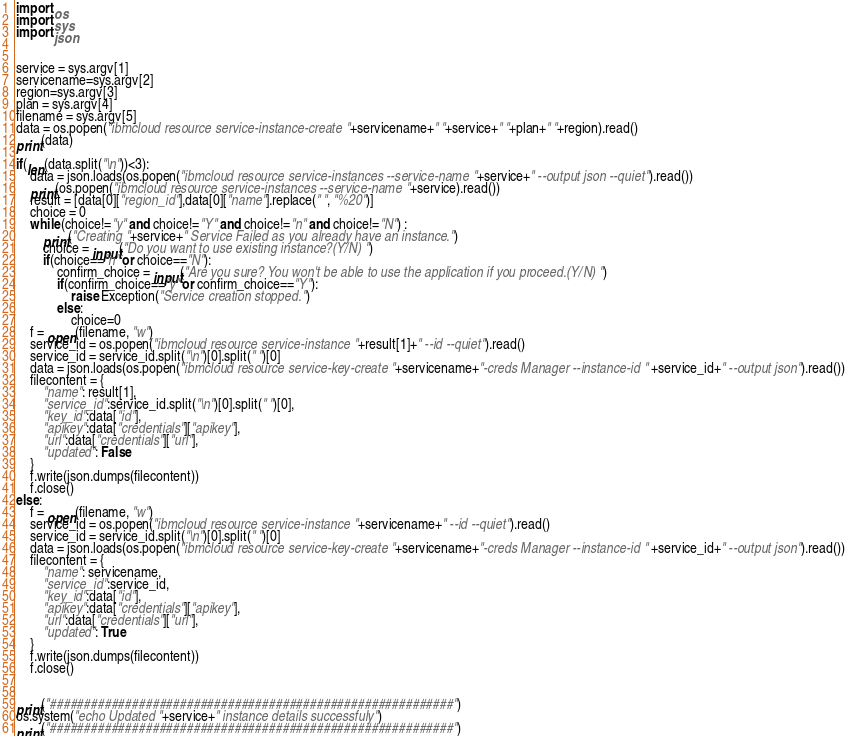Convert code to text. <code><loc_0><loc_0><loc_500><loc_500><_Python_>import os
import sys
import json


service = sys.argv[1]
servicename=sys.argv[2]
region=sys.argv[3]
plan = sys.argv[4]
filename = sys.argv[5]
data = os.popen("ibmcloud resource service-instance-create "+servicename+" "+service+" "+plan+" "+region).read()
print(data)

if(len(data.split("\n"))<3):
    data = json.loads(os.popen("ibmcloud resource service-instances --service-name "+service+" --output json --quiet").read())
    print(os.popen("ibmcloud resource service-instances --service-name "+service).read())
    result = [data[0]["region_id"],data[0]["name"].replace(" ", "%20")]
    choice = 0
    while (choice!="y" and choice!="Y" and choice!="n" and choice!="N") :
        print("Creating "+service+" Service Failed as you already have an instance.")
        choice = input("Do you want to use existing instance?(Y/N) ")
        if(choice=="n" or choice=="N"):
            confirm_choice = input("Are you sure? You won't be able to use the application if you proceed.(Y/N) ")
            if(confirm_choice=="y" or confirm_choice=="Y"):
                raise Exception("Service creation stopped.")
            else:
                choice=0
    f = open(filename, "w")
    service_id = os.popen("ibmcloud resource service-instance "+result[1]+" --id --quiet").read()
    service_id = service_id.split("\n")[0].split(" ")[0]
    data = json.loads(os.popen("ibmcloud resource service-key-create "+servicename+"-creds Manager --instance-id " +service_id+" --output json").read())
    filecontent = {
        "name": result[1],
        "service_id":service_id.split("\n")[0].split(" ")[0],
        "key_id":data["id"],
        "apikey":data["credentials"]["apikey"],
        "url":data["credentials"]["url"],
        "updated": False
    }
    f.write(json.dumps(filecontent))
    f.close()
else:
    f = open(filename, "w")
    service_id = os.popen("ibmcloud resource service-instance "+servicename+" --id --quiet").read()
    service_id = service_id.split("\n")[0].split(" ")[0]
    data = json.loads(os.popen("ibmcloud resource service-key-create "+servicename+"-creds Manager --instance-id " +service_id+" --output json").read())
    filecontent = {
        "name": servicename,
        "service_id":service_id,
        "key_id":data["id"],
        "apikey":data["credentials"]["apikey"],
        "url":data["credentials"]["url"],
        "updated": True
    }
    f.write(json.dumps(filecontent))
    f.close()


print("###########################################################")        
os.system("echo Updated "+service+" instance details successfuly")
print("###########################################################")   </code> 